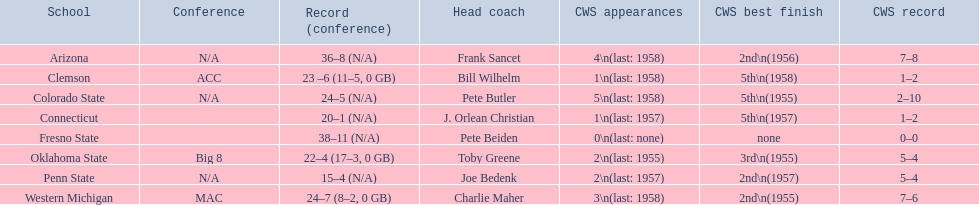What are the specified schools? Arizona, Clemson, Colorado State, Connecticut, Fresno State, Oklahoma State, Penn State, Western Michigan. Which involve clemson and western michigan? Clemson, Western Michigan. What are their corresponding numbers of cws showings? 1\n(last: 1958), 3\n(last: 1958). Which value is higher? 3\n(last: 1958). To which school does that value relate? Western Michigan. 